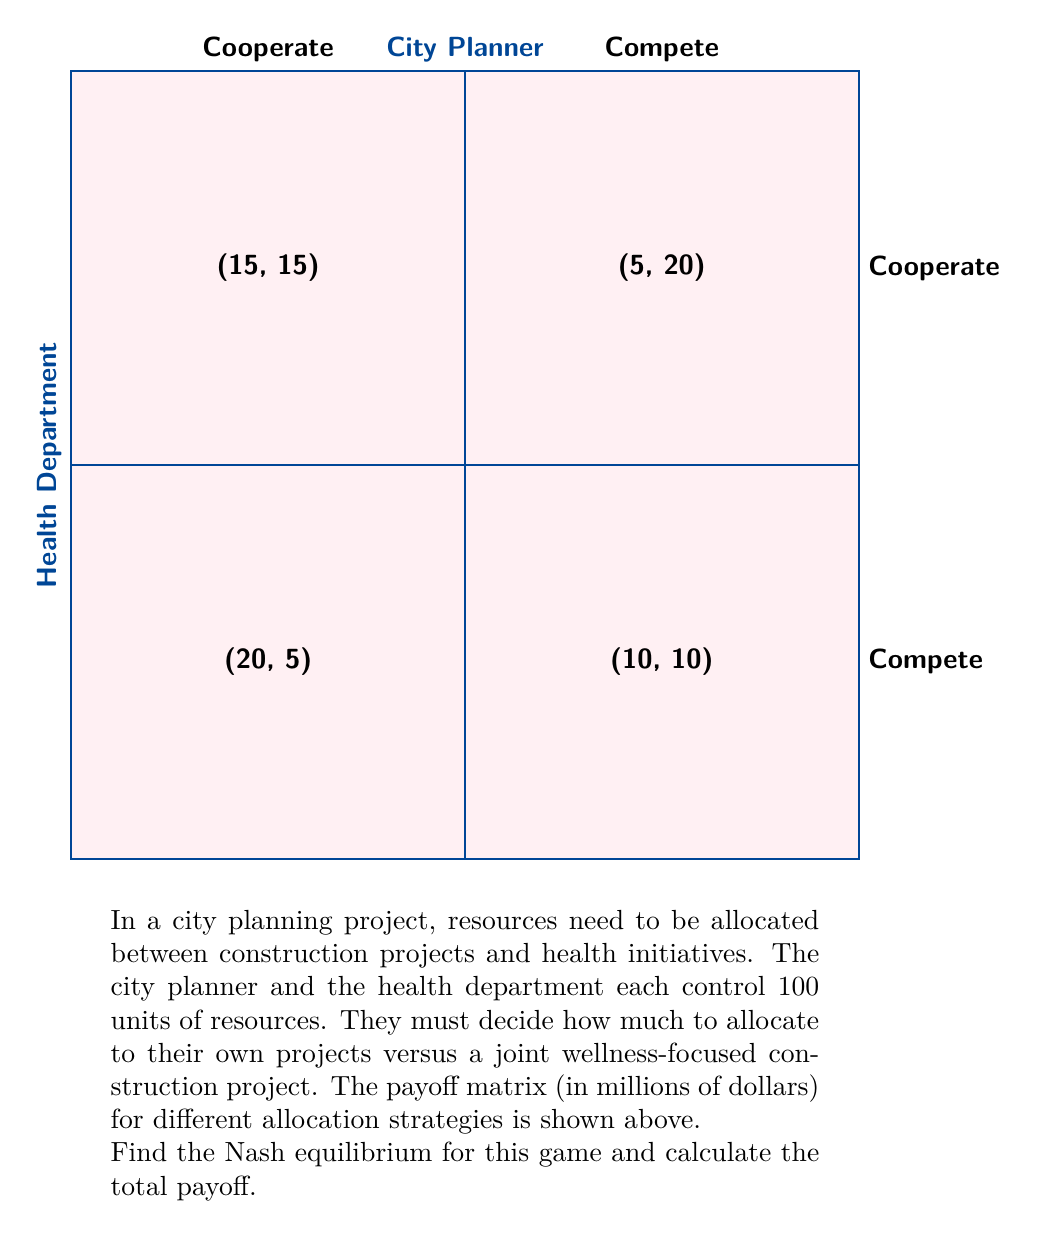Provide a solution to this math problem. To find the Nash equilibrium, we need to analyze each player's best response to the other player's strategy:

1. City Planner's perspective:
   - If Health Department cooperates:
     Cooperate: 15, Compete: 20 (best response)
   - If Health Department competes:
     Cooperate: 5, Compete: 10 (best response)

2. Health Department's perspective:
   - If City Planner cooperates:
     Cooperate: 15, Compete: 20 (best response)
   - If City Planner competes:
     Cooperate: 5, Compete: 10 (best response)

Both players have a dominant strategy to compete, regardless of what the other player does. Therefore, the Nash equilibrium is (Compete, Compete).

To calculate the total payoff:
$$ \text{Total Payoff} = \text{City Planner's Payoff} + \text{Health Department's Payoff} $$
$$ \text{Total Payoff} = 10 + 10 = 20 \text{ million dollars} $$

This results in a suboptimal outcome compared to if both had cooperated (which would have yielded a total payoff of 30 million dollars). This situation demonstrates the "Prisoner's Dilemma" in game theory, where individual rational choices lead to a collectively suboptimal outcome.
Answer: Nash equilibrium: (Compete, Compete); Total payoff: $20 million 